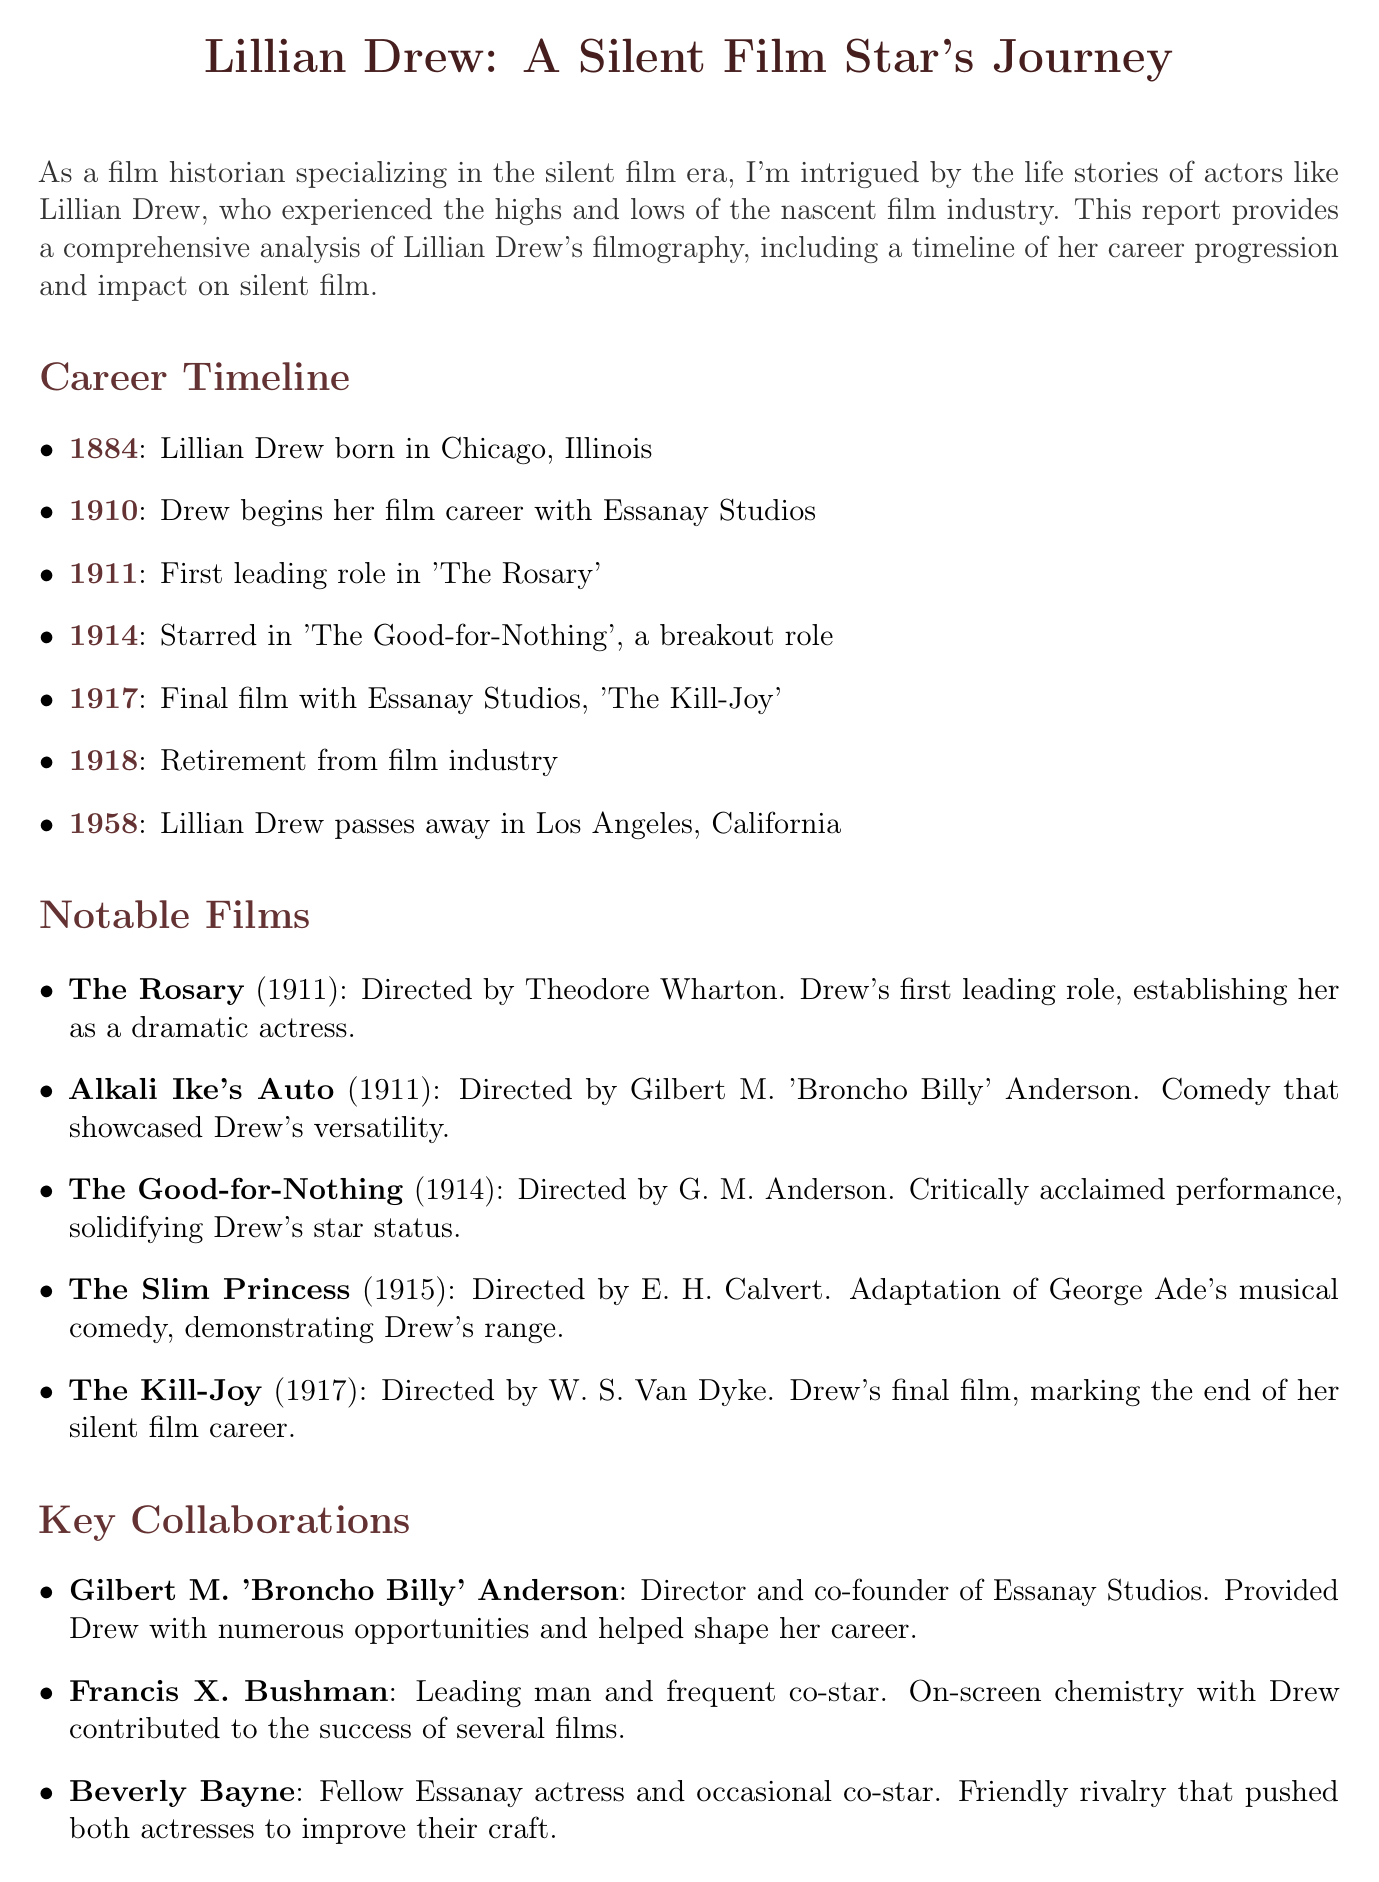what year was Lillian Drew born? The document states that Lillian Drew was born in 1884.
Answer: 1884 what is the title of Lillian Drew's first leading role? According to the document, her first leading role was in "The Rosary".
Answer: The Rosary which film marked Lillian Drew's final appearance? The document mentions that her final film was "The Kill-Joy".
Answer: The Kill-Joy who directed "The Good-for-Nothing"? The document specifies that "The Good-for-Nothing" was directed by G. M. Anderson.
Answer: G. M. Anderson how did Lillian Drew influence acting techniques in silent films? The document describes her impact as helping develop a more naturalistic style of film acting.
Answer: Naturalistic style what aspect of representation did Lillian Drew challenge in her films? The document indicates she portrayed strong, independent women, challenging societal norms.
Answer: Strong, independent women what year did Lillian Drew retire from the film industry? According to the document, she retired in 1918.
Answer: 1918 what organization is involved in the restoration of "The Good-for-Nothing"? The document notes that the National Film Preservation Foundation is involved in the restoration.
Answer: National Film Preservation Foundation who was Lillian Drew's frequent co-star? The document mentions Francis X. Bushman as her frequent co-star.
Answer: Francis X. Bushman 